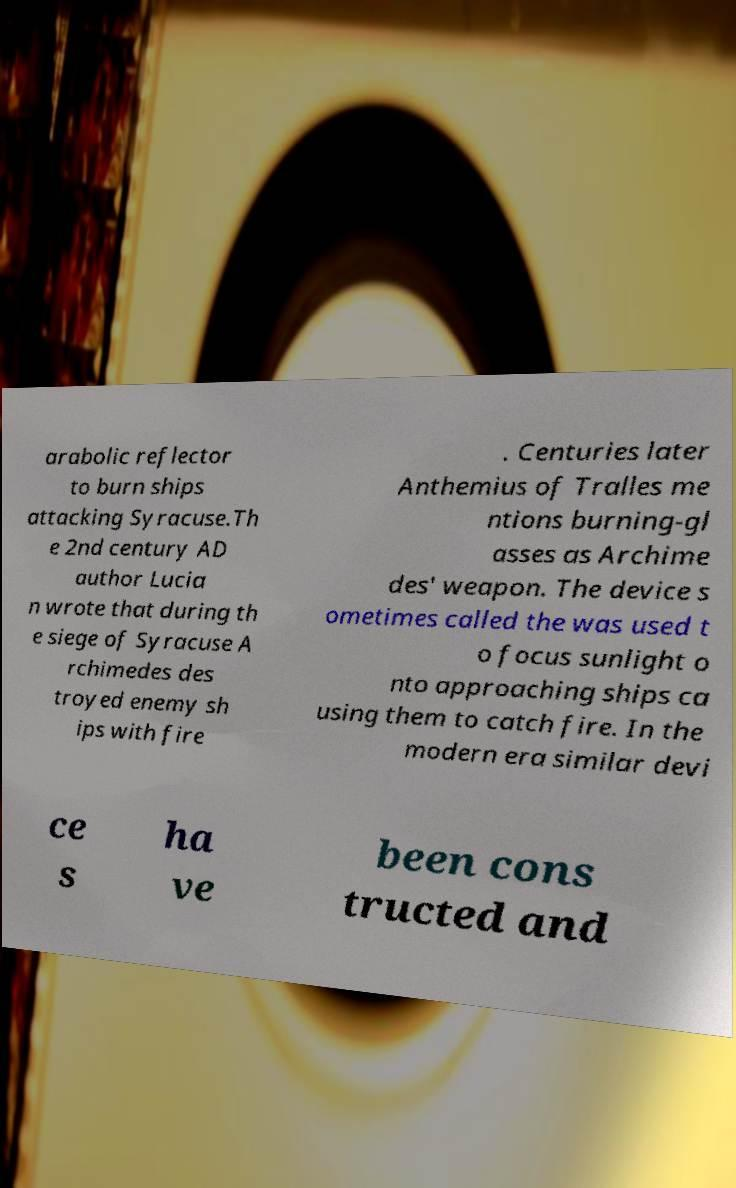Could you extract and type out the text from this image? arabolic reflector to burn ships attacking Syracuse.Th e 2nd century AD author Lucia n wrote that during th e siege of Syracuse A rchimedes des troyed enemy sh ips with fire . Centuries later Anthemius of Tralles me ntions burning-gl asses as Archime des' weapon. The device s ometimes called the was used t o focus sunlight o nto approaching ships ca using them to catch fire. In the modern era similar devi ce s ha ve been cons tructed and 